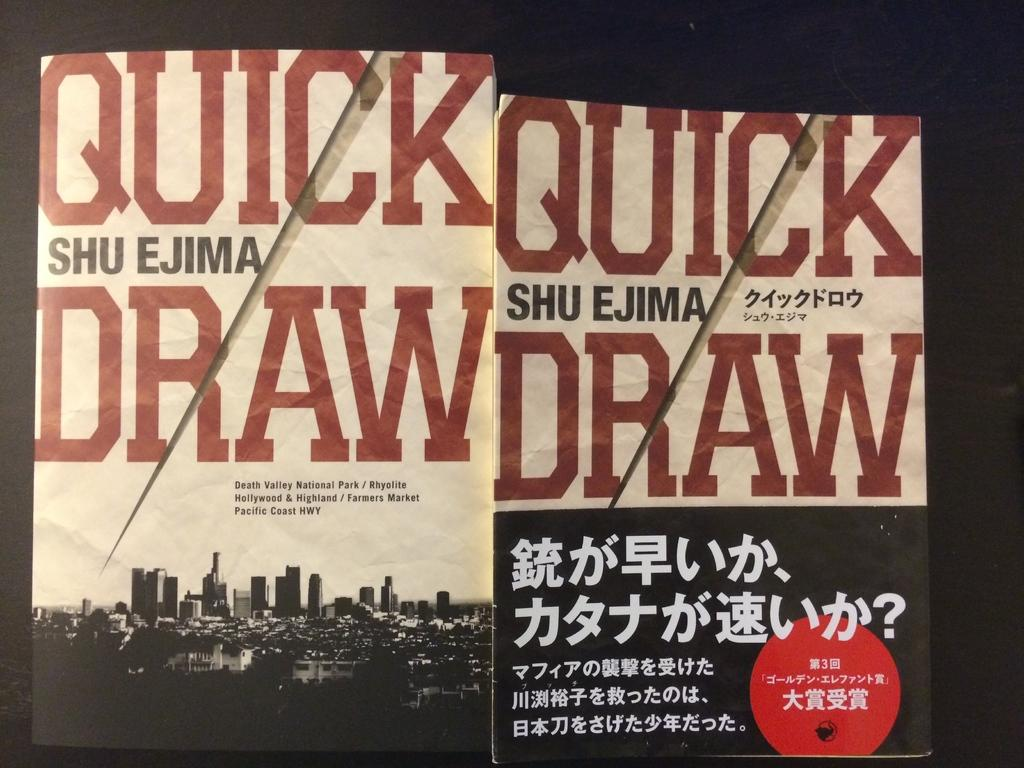Provide a one-sentence caption for the provided image. Two copies of the novel Quick Draw by Shu Ejima. 